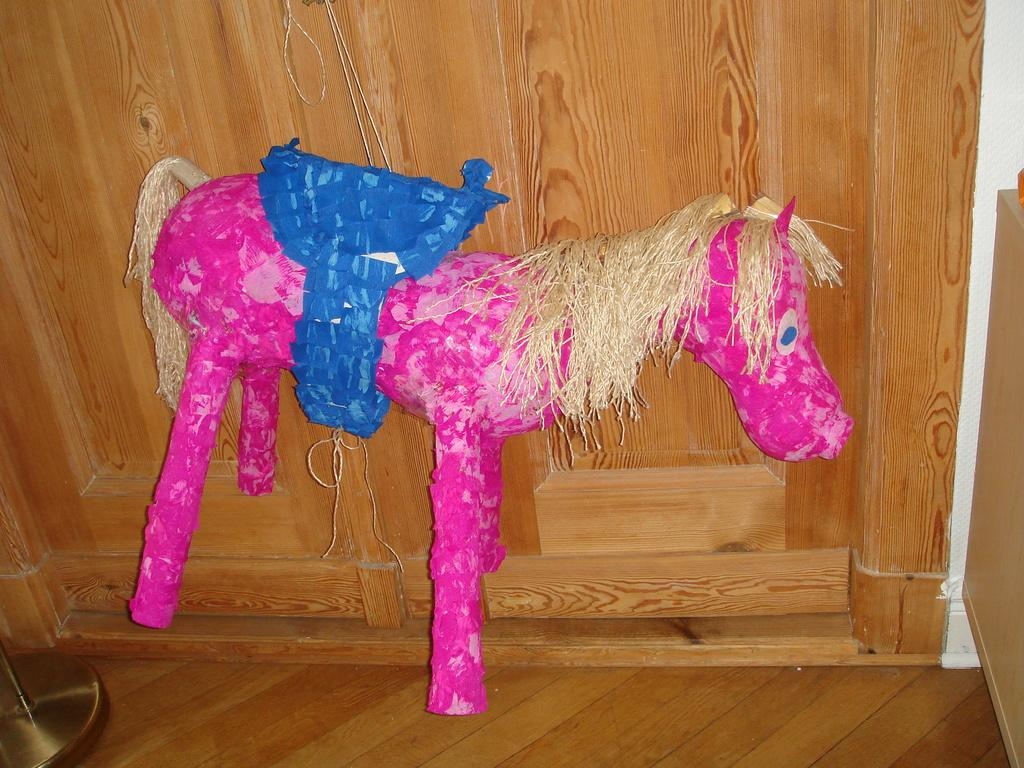What can be seen in the image that is meant for play or entertainment? There is a toy in the image. What material is the floor made of in the image? The floor in the image is made of wood. What else is present in the image besides the toy? There are objects in the image. What type of wall can be seen in the background of the image? There is a wooden wall in the background of the image. Where is the cattle grazing in the image? There is no cattle present in the image. Is there a stream visible in the image? There is no stream visible in the image. 